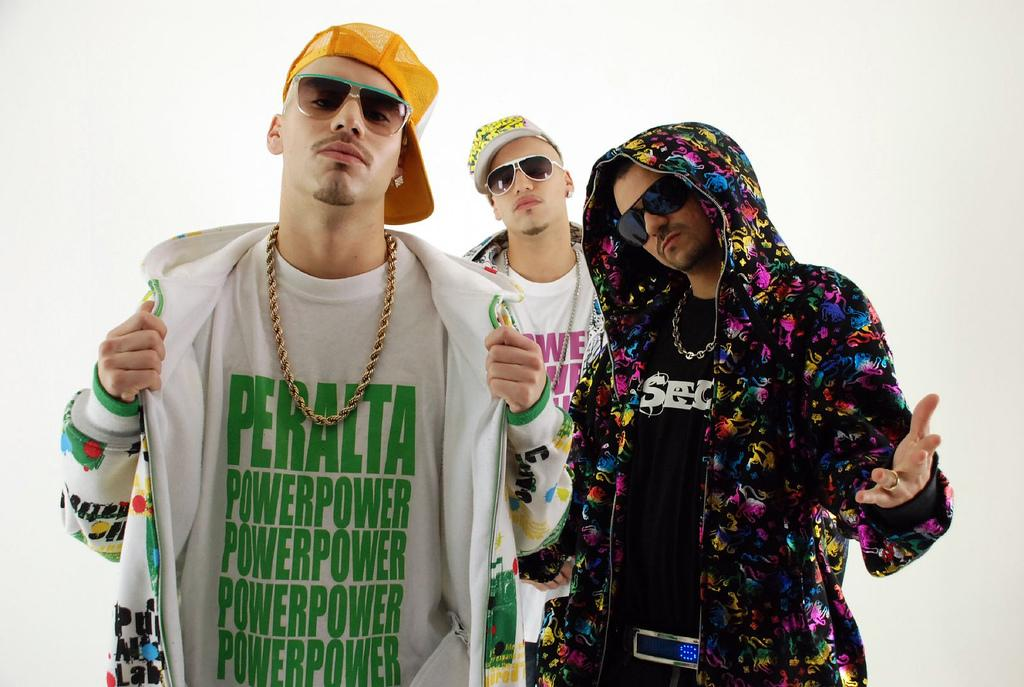How many people are in the image? There are three men standing in the image. What are the men wearing on their heads? The men are wearing caps. What type of eyewear are the men using? The men are wearing goggles. What is the color of the background in the image? The background of the image is white in color. What type of bait is being used by the men in the image? There is no bait present in the image; the men are wearing goggles and caps. Can you tell me how many marbles are on the ground in the image? There are no marbles visible in the image; the focus is on the three men and their attire. 